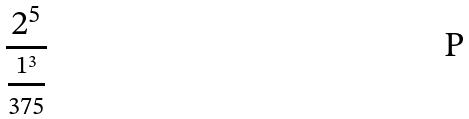Convert formula to latex. <formula><loc_0><loc_0><loc_500><loc_500>\frac { 2 ^ { 5 } } { \frac { 1 ^ { 3 } } { 3 7 5 } }</formula> 